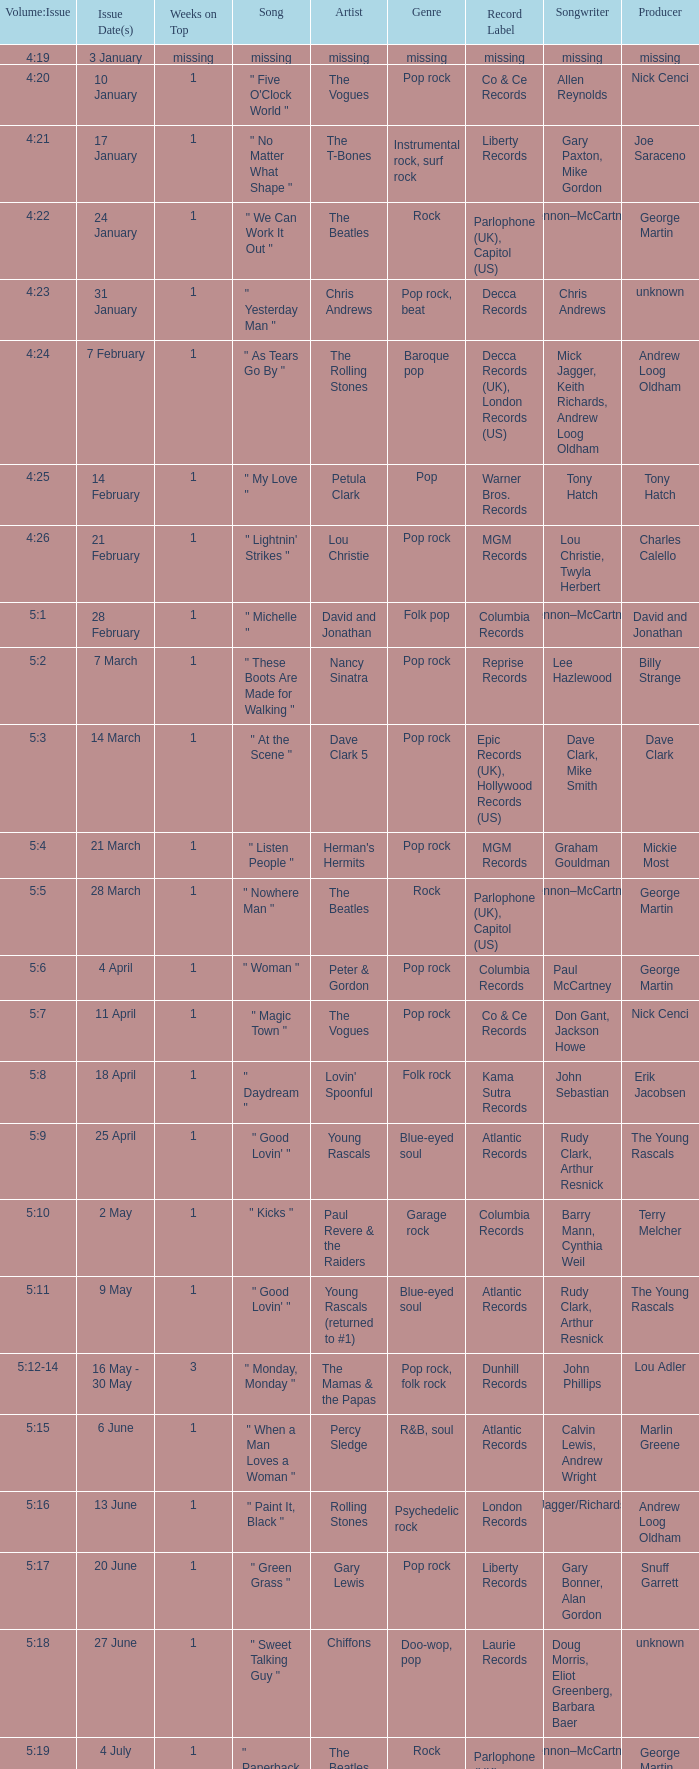With an issue date(s) of 12 September, what is in the column for Weeks on Top? 1.0. 